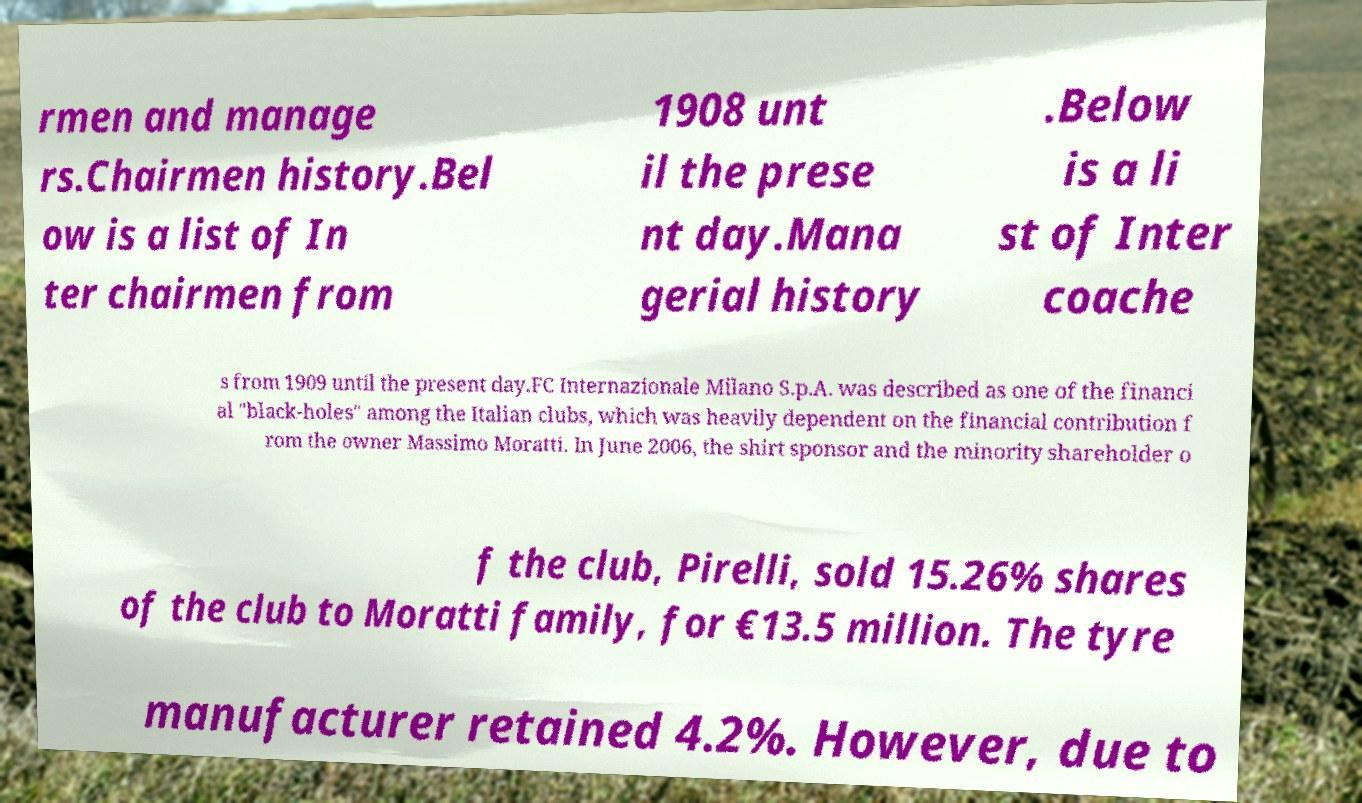What messages or text are displayed in this image? I need them in a readable, typed format. rmen and manage rs.Chairmen history.Bel ow is a list of In ter chairmen from 1908 unt il the prese nt day.Mana gerial history .Below is a li st of Inter coache s from 1909 until the present day.FC Internazionale Milano S.p.A. was described as one of the financi al "black-holes" among the Italian clubs, which was heavily dependent on the financial contribution f rom the owner Massimo Moratti. In June 2006, the shirt sponsor and the minority shareholder o f the club, Pirelli, sold 15.26% shares of the club to Moratti family, for €13.5 million. The tyre manufacturer retained 4.2%. However, due to 